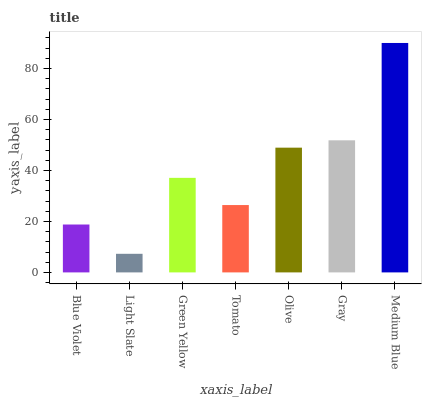Is Light Slate the minimum?
Answer yes or no. Yes. Is Medium Blue the maximum?
Answer yes or no. Yes. Is Green Yellow the minimum?
Answer yes or no. No. Is Green Yellow the maximum?
Answer yes or no. No. Is Green Yellow greater than Light Slate?
Answer yes or no. Yes. Is Light Slate less than Green Yellow?
Answer yes or no. Yes. Is Light Slate greater than Green Yellow?
Answer yes or no. No. Is Green Yellow less than Light Slate?
Answer yes or no. No. Is Green Yellow the high median?
Answer yes or no. Yes. Is Green Yellow the low median?
Answer yes or no. Yes. Is Blue Violet the high median?
Answer yes or no. No. Is Medium Blue the low median?
Answer yes or no. No. 